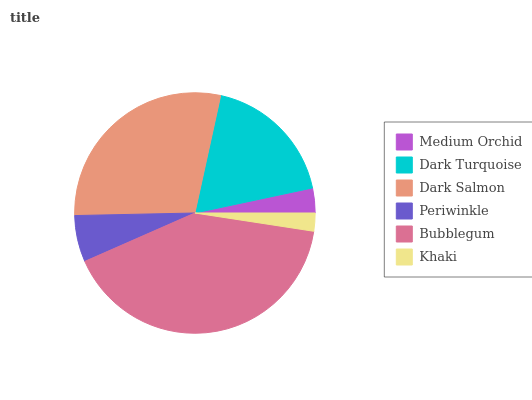Is Khaki the minimum?
Answer yes or no. Yes. Is Bubblegum the maximum?
Answer yes or no. Yes. Is Dark Turquoise the minimum?
Answer yes or no. No. Is Dark Turquoise the maximum?
Answer yes or no. No. Is Dark Turquoise greater than Medium Orchid?
Answer yes or no. Yes. Is Medium Orchid less than Dark Turquoise?
Answer yes or no. Yes. Is Medium Orchid greater than Dark Turquoise?
Answer yes or no. No. Is Dark Turquoise less than Medium Orchid?
Answer yes or no. No. Is Dark Turquoise the high median?
Answer yes or no. Yes. Is Periwinkle the low median?
Answer yes or no. Yes. Is Khaki the high median?
Answer yes or no. No. Is Medium Orchid the low median?
Answer yes or no. No. 